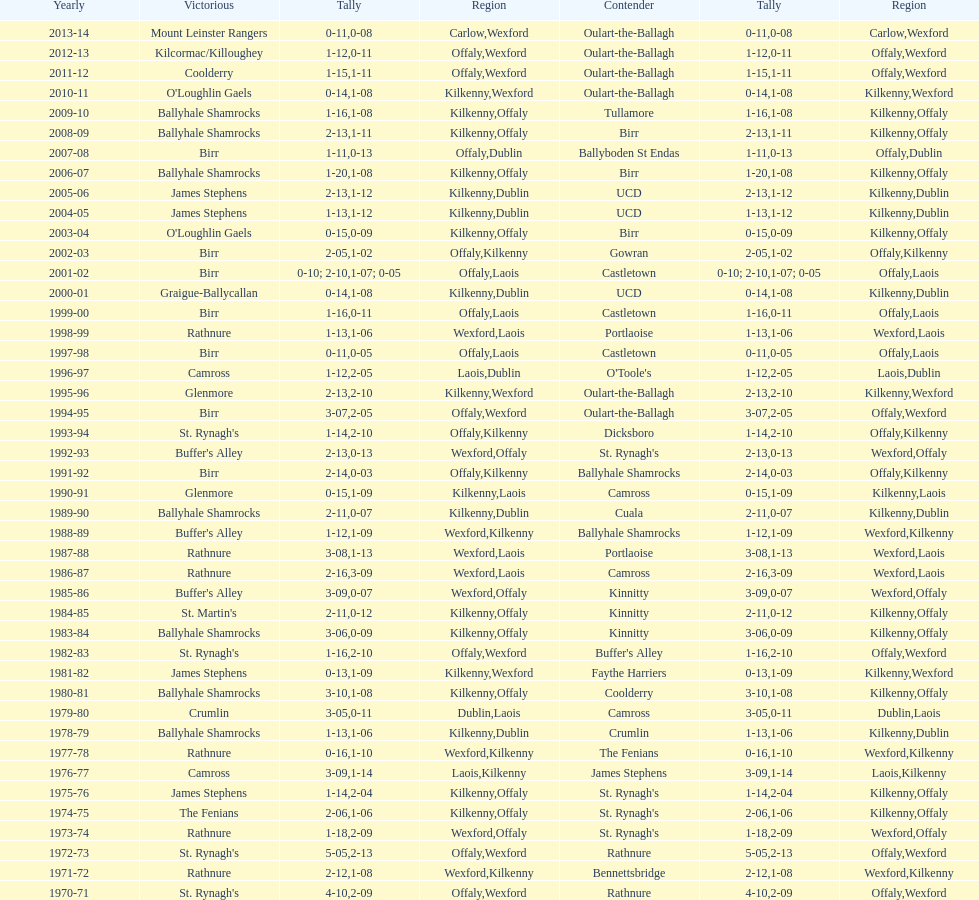How many consecutive years did rathnure win? 2. 